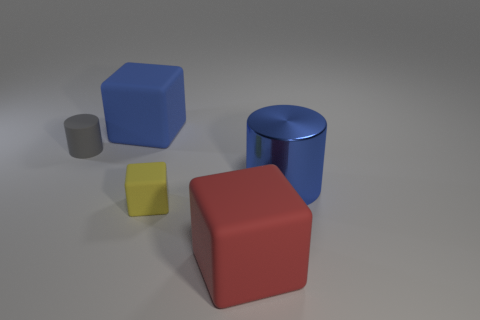Subtract all big blocks. How many blocks are left? 1 Add 5 large gray cubes. How many objects exist? 10 Subtract 1 cubes. How many cubes are left? 2 Subtract all red blocks. How many blocks are left? 2 Add 4 cylinders. How many cylinders exist? 6 Subtract 0 yellow spheres. How many objects are left? 5 Subtract all cylinders. How many objects are left? 3 Subtract all cyan cylinders. Subtract all yellow balls. How many cylinders are left? 2 Subtract all red cylinders. How many red cubes are left? 1 Subtract all large blue cubes. Subtract all matte things. How many objects are left? 0 